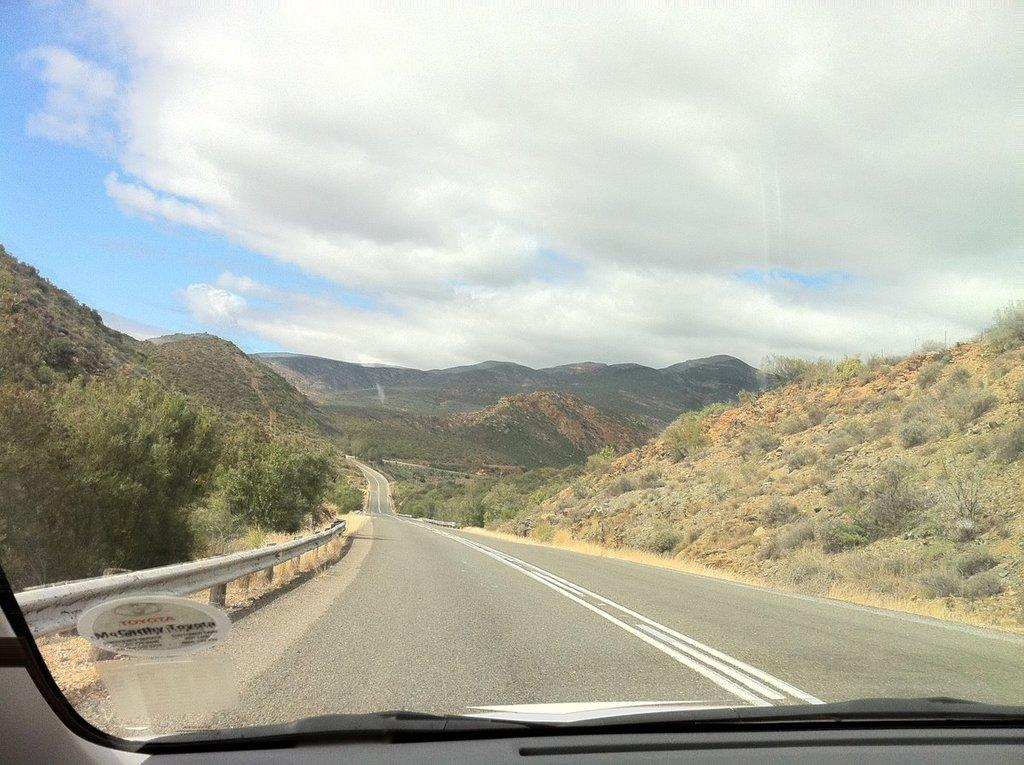What type of natural formation can be seen in the background of the image? There are mountains in the background of the image. What type of vegetation is present on the right side of the image? There are trees on the right side of the image. What type of vegetation is present in the image, but different from the trees? There are dry plants in the image. What is the condition of the sky in the image? The sky is cloudy in the image. What type of net can be seen in the image? There is no net present in the image. 